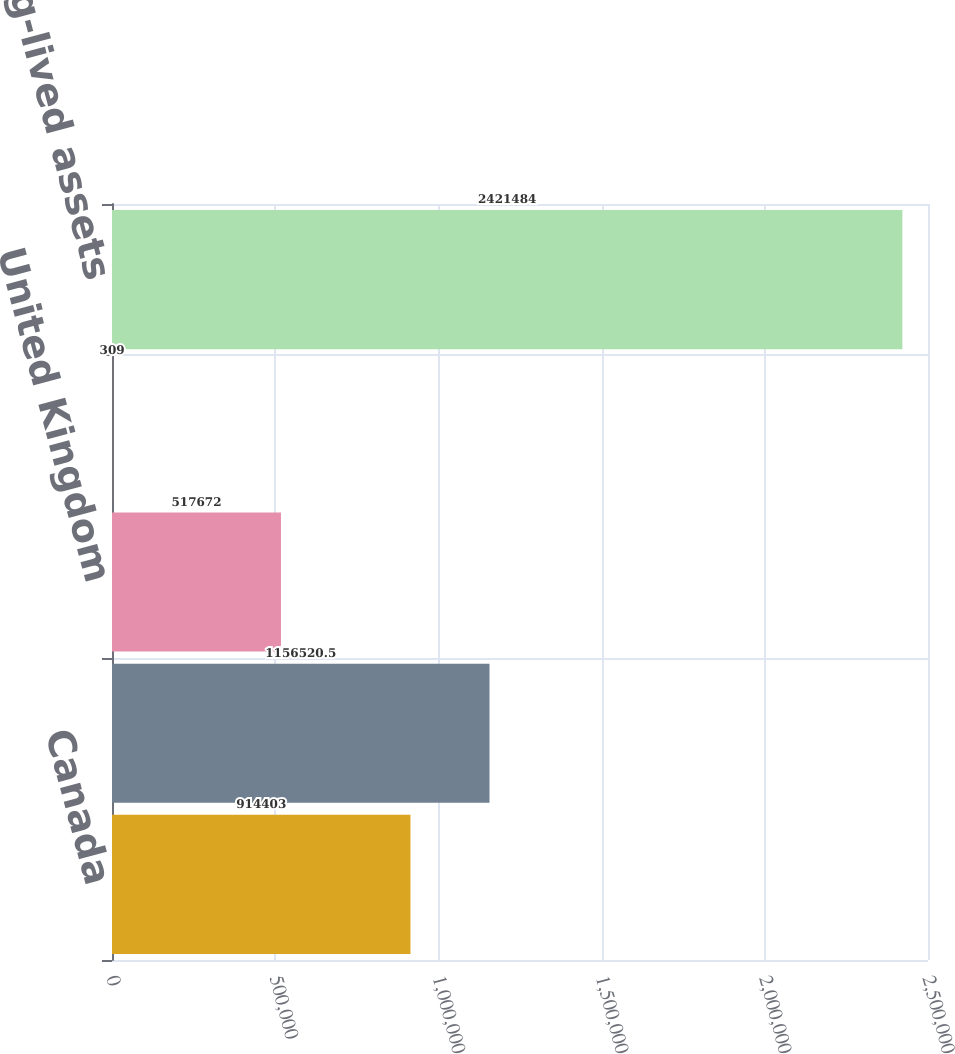<chart> <loc_0><loc_0><loc_500><loc_500><bar_chart><fcel>Canada<fcel>United States and its<fcel>United Kingdom<fcel>Other foreign countries<fcel>Consolidated long-lived assets<nl><fcel>914403<fcel>1.15652e+06<fcel>517672<fcel>309<fcel>2.42148e+06<nl></chart> 